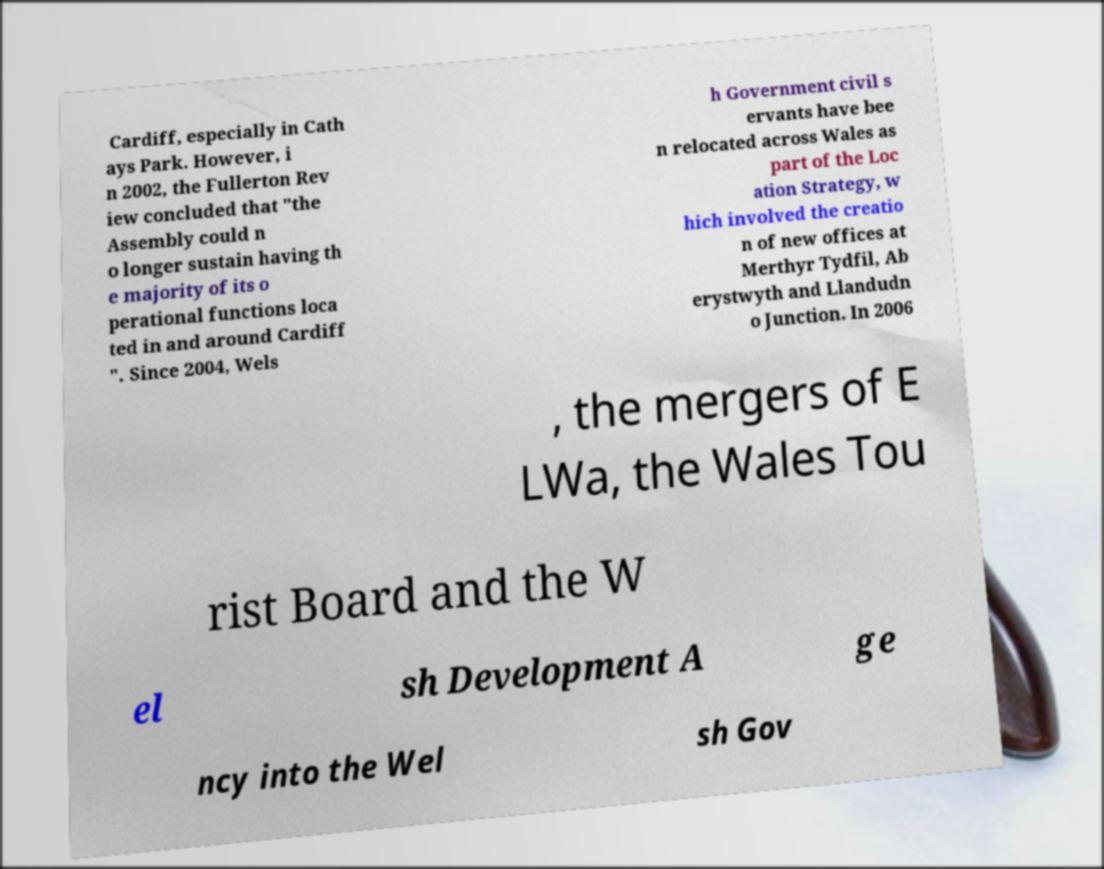What messages or text are displayed in this image? I need them in a readable, typed format. Cardiff, especially in Cath ays Park. However, i n 2002, the Fullerton Rev iew concluded that "the Assembly could n o longer sustain having th e majority of its o perational functions loca ted in and around Cardiff ". Since 2004, Wels h Government civil s ervants have bee n relocated across Wales as part of the Loc ation Strategy, w hich involved the creatio n of new offices at Merthyr Tydfil, Ab erystwyth and Llandudn o Junction. In 2006 , the mergers of E LWa, the Wales Tou rist Board and the W el sh Development A ge ncy into the Wel sh Gov 